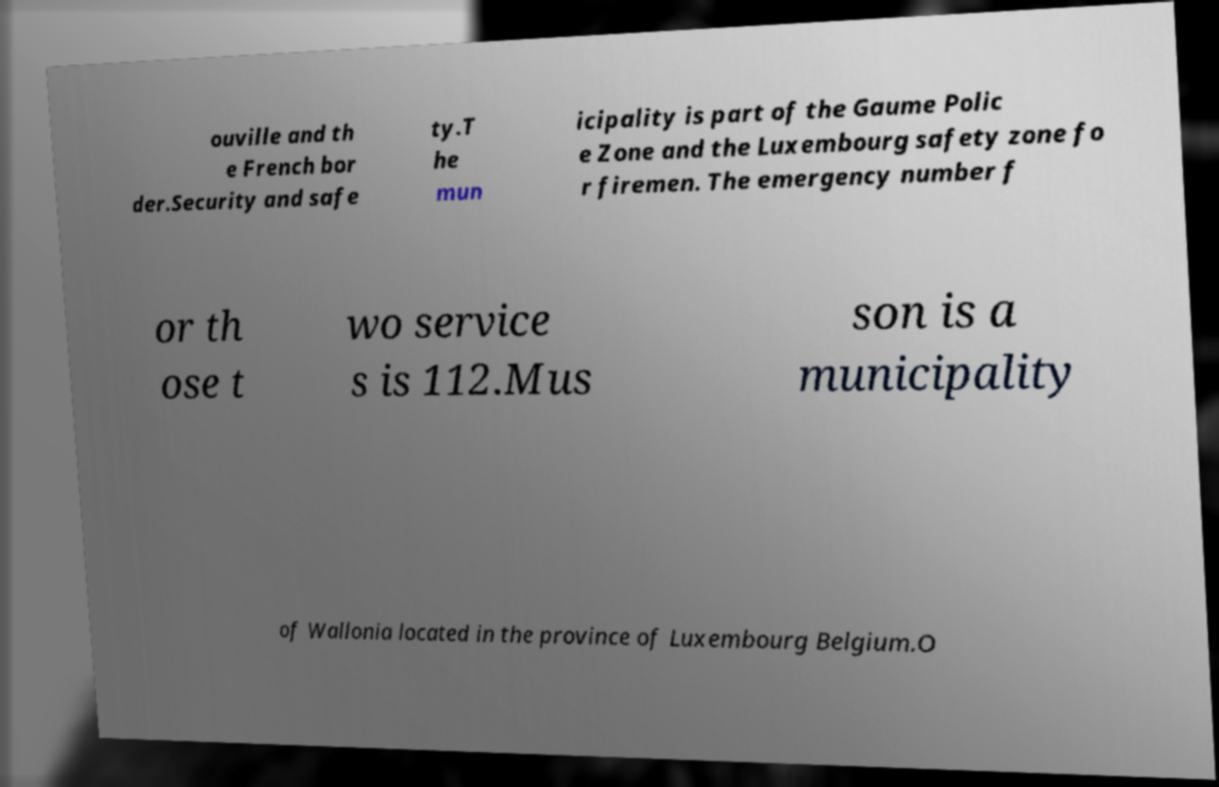Please identify and transcribe the text found in this image. ouville and th e French bor der.Security and safe ty.T he mun icipality is part of the Gaume Polic e Zone and the Luxembourg safety zone fo r firemen. The emergency number f or th ose t wo service s is 112.Mus son is a municipality of Wallonia located in the province of Luxembourg Belgium.O 